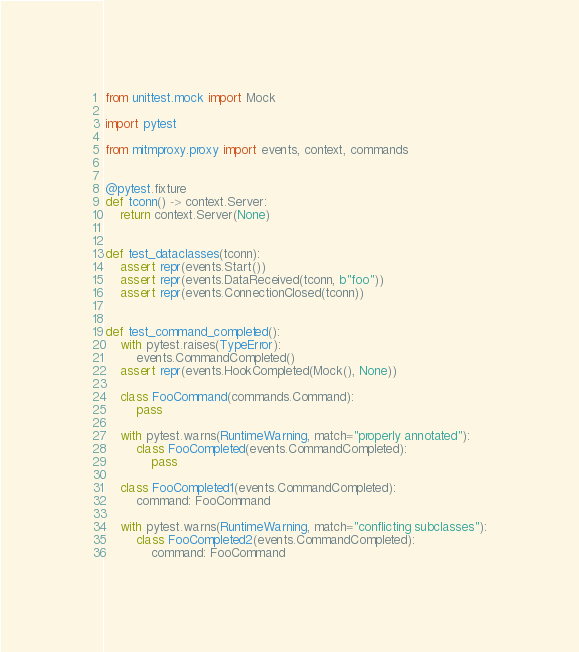<code> <loc_0><loc_0><loc_500><loc_500><_Python_>from unittest.mock import Mock

import pytest

from mitmproxy.proxy import events, context, commands


@pytest.fixture
def tconn() -> context.Server:
    return context.Server(None)


def test_dataclasses(tconn):
    assert repr(events.Start())
    assert repr(events.DataReceived(tconn, b"foo"))
    assert repr(events.ConnectionClosed(tconn))


def test_command_completed():
    with pytest.raises(TypeError):
        events.CommandCompleted()
    assert repr(events.HookCompleted(Mock(), None))

    class FooCommand(commands.Command):
        pass

    with pytest.warns(RuntimeWarning, match="properly annotated"):
        class FooCompleted(events.CommandCompleted):
            pass

    class FooCompleted1(events.CommandCompleted):
        command: FooCommand

    with pytest.warns(RuntimeWarning, match="conflicting subclasses"):
        class FooCompleted2(events.CommandCompleted):
            command: FooCommand
</code> 